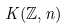Convert formula to latex. <formula><loc_0><loc_0><loc_500><loc_500>K ( \mathbb { Z } , n )</formula> 